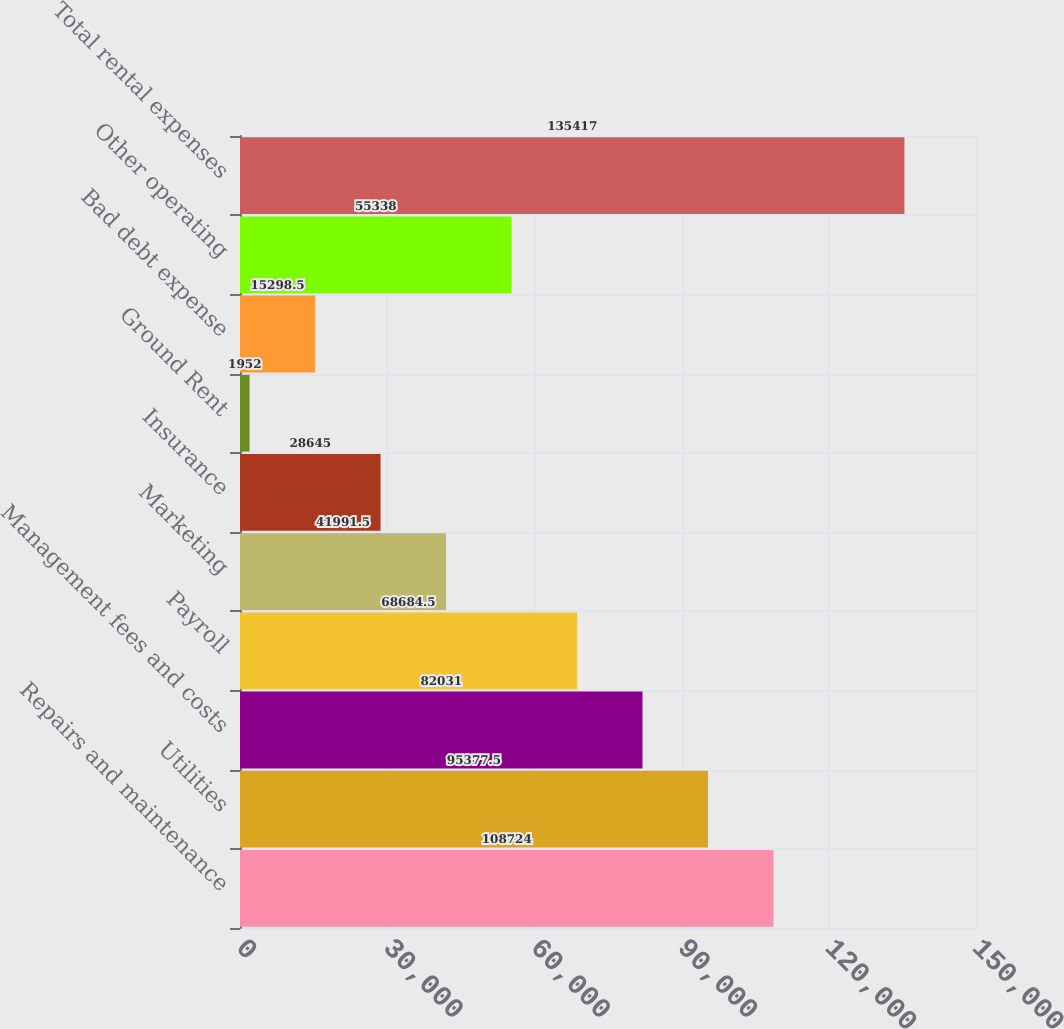Convert chart. <chart><loc_0><loc_0><loc_500><loc_500><bar_chart><fcel>Repairs and maintenance<fcel>Utilities<fcel>Management fees and costs<fcel>Payroll<fcel>Marketing<fcel>Insurance<fcel>Ground Rent<fcel>Bad debt expense<fcel>Other operating<fcel>Total rental expenses<nl><fcel>108724<fcel>95377.5<fcel>82031<fcel>68684.5<fcel>41991.5<fcel>28645<fcel>1952<fcel>15298.5<fcel>55338<fcel>135417<nl></chart> 